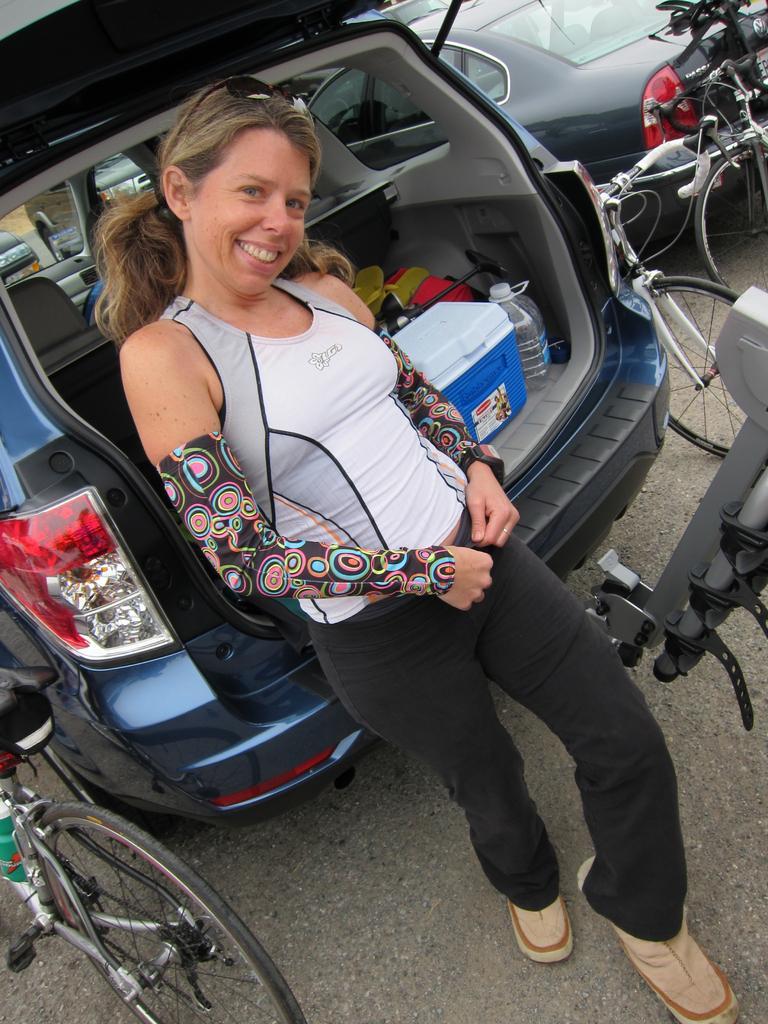In one or two sentences, can you explain what this image depicts? In the middle of the image a woman is standing. Behind her there are some vehicles and bicycles and she is smiling. 